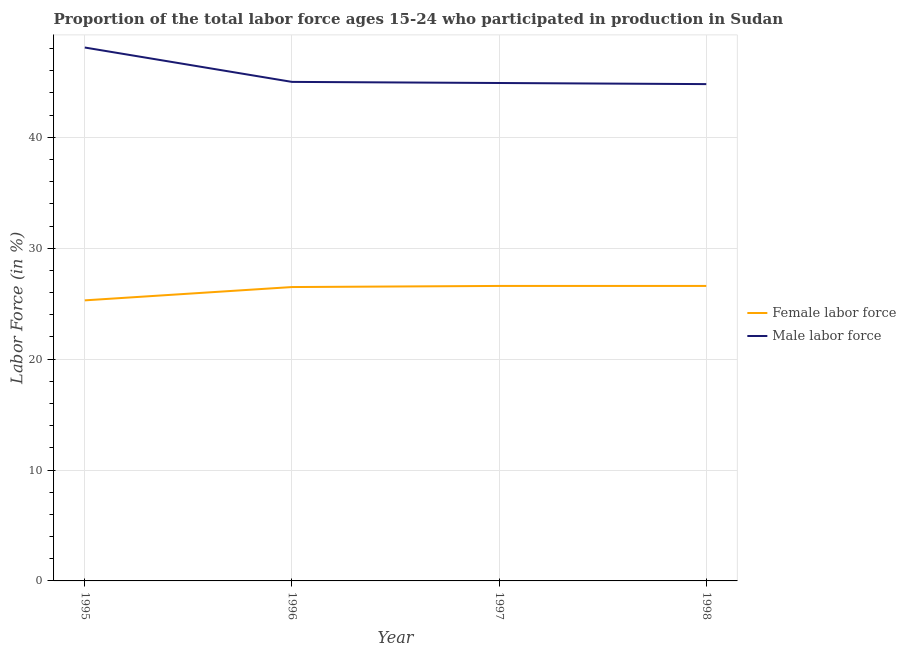Does the line corresponding to percentage of female labor force intersect with the line corresponding to percentage of male labour force?
Provide a short and direct response. No. What is the percentage of female labor force in 1995?
Keep it short and to the point. 25.3. Across all years, what is the maximum percentage of male labour force?
Your answer should be very brief. 48.1. Across all years, what is the minimum percentage of female labor force?
Ensure brevity in your answer.  25.3. In which year was the percentage of female labor force maximum?
Provide a succinct answer. 1997. What is the total percentage of male labour force in the graph?
Give a very brief answer. 182.8. What is the difference between the percentage of male labour force in 1996 and that in 1997?
Keep it short and to the point. 0.1. What is the difference between the percentage of male labour force in 1997 and the percentage of female labor force in 1995?
Your answer should be very brief. 19.6. What is the average percentage of male labour force per year?
Give a very brief answer. 45.7. In the year 1997, what is the difference between the percentage of female labor force and percentage of male labour force?
Give a very brief answer. -18.3. What is the ratio of the percentage of female labor force in 1996 to that in 1998?
Your answer should be very brief. 1. What is the difference between the highest and the second highest percentage of male labour force?
Provide a succinct answer. 3.1. What is the difference between the highest and the lowest percentage of male labour force?
Keep it short and to the point. 3.3. In how many years, is the percentage of female labor force greater than the average percentage of female labor force taken over all years?
Provide a succinct answer. 3. Does the percentage of male labour force monotonically increase over the years?
Offer a very short reply. No. How many lines are there?
Your response must be concise. 2. What is the difference between two consecutive major ticks on the Y-axis?
Provide a short and direct response. 10. Does the graph contain any zero values?
Provide a short and direct response. No. Where does the legend appear in the graph?
Offer a terse response. Center right. What is the title of the graph?
Offer a terse response. Proportion of the total labor force ages 15-24 who participated in production in Sudan. What is the label or title of the X-axis?
Ensure brevity in your answer.  Year. What is the label or title of the Y-axis?
Keep it short and to the point. Labor Force (in %). What is the Labor Force (in %) in Female labor force in 1995?
Make the answer very short. 25.3. What is the Labor Force (in %) in Male labor force in 1995?
Make the answer very short. 48.1. What is the Labor Force (in %) of Female labor force in 1997?
Keep it short and to the point. 26.6. What is the Labor Force (in %) in Male labor force in 1997?
Your answer should be compact. 44.9. What is the Labor Force (in %) of Female labor force in 1998?
Ensure brevity in your answer.  26.6. What is the Labor Force (in %) of Male labor force in 1998?
Give a very brief answer. 44.8. Across all years, what is the maximum Labor Force (in %) of Female labor force?
Your answer should be very brief. 26.6. Across all years, what is the maximum Labor Force (in %) of Male labor force?
Make the answer very short. 48.1. Across all years, what is the minimum Labor Force (in %) in Female labor force?
Ensure brevity in your answer.  25.3. Across all years, what is the minimum Labor Force (in %) of Male labor force?
Offer a terse response. 44.8. What is the total Labor Force (in %) in Female labor force in the graph?
Offer a very short reply. 105. What is the total Labor Force (in %) in Male labor force in the graph?
Offer a terse response. 182.8. What is the difference between the Labor Force (in %) in Male labor force in 1995 and that in 1996?
Give a very brief answer. 3.1. What is the difference between the Labor Force (in %) in Female labor force in 1995 and that in 1997?
Your answer should be compact. -1.3. What is the difference between the Labor Force (in %) in Male labor force in 1995 and that in 1997?
Provide a succinct answer. 3.2. What is the difference between the Labor Force (in %) in Female labor force in 1995 and that in 1998?
Your response must be concise. -1.3. What is the difference between the Labor Force (in %) of Female labor force in 1996 and that in 1998?
Your response must be concise. -0.1. What is the difference between the Labor Force (in %) in Male labor force in 1996 and that in 1998?
Keep it short and to the point. 0.2. What is the difference between the Labor Force (in %) in Female labor force in 1997 and that in 1998?
Your answer should be compact. 0. What is the difference between the Labor Force (in %) in Female labor force in 1995 and the Labor Force (in %) in Male labor force in 1996?
Make the answer very short. -19.7. What is the difference between the Labor Force (in %) in Female labor force in 1995 and the Labor Force (in %) in Male labor force in 1997?
Provide a short and direct response. -19.6. What is the difference between the Labor Force (in %) in Female labor force in 1995 and the Labor Force (in %) in Male labor force in 1998?
Give a very brief answer. -19.5. What is the difference between the Labor Force (in %) in Female labor force in 1996 and the Labor Force (in %) in Male labor force in 1997?
Offer a very short reply. -18.4. What is the difference between the Labor Force (in %) in Female labor force in 1996 and the Labor Force (in %) in Male labor force in 1998?
Your response must be concise. -18.3. What is the difference between the Labor Force (in %) of Female labor force in 1997 and the Labor Force (in %) of Male labor force in 1998?
Offer a very short reply. -18.2. What is the average Labor Force (in %) in Female labor force per year?
Your response must be concise. 26.25. What is the average Labor Force (in %) in Male labor force per year?
Give a very brief answer. 45.7. In the year 1995, what is the difference between the Labor Force (in %) of Female labor force and Labor Force (in %) of Male labor force?
Your response must be concise. -22.8. In the year 1996, what is the difference between the Labor Force (in %) in Female labor force and Labor Force (in %) in Male labor force?
Provide a succinct answer. -18.5. In the year 1997, what is the difference between the Labor Force (in %) in Female labor force and Labor Force (in %) in Male labor force?
Keep it short and to the point. -18.3. In the year 1998, what is the difference between the Labor Force (in %) of Female labor force and Labor Force (in %) of Male labor force?
Keep it short and to the point. -18.2. What is the ratio of the Labor Force (in %) of Female labor force in 1995 to that in 1996?
Give a very brief answer. 0.95. What is the ratio of the Labor Force (in %) in Male labor force in 1995 to that in 1996?
Offer a very short reply. 1.07. What is the ratio of the Labor Force (in %) of Female labor force in 1995 to that in 1997?
Ensure brevity in your answer.  0.95. What is the ratio of the Labor Force (in %) in Male labor force in 1995 to that in 1997?
Provide a succinct answer. 1.07. What is the ratio of the Labor Force (in %) of Female labor force in 1995 to that in 1998?
Your answer should be compact. 0.95. What is the ratio of the Labor Force (in %) in Male labor force in 1995 to that in 1998?
Provide a short and direct response. 1.07. What is the ratio of the Labor Force (in %) of Female labor force in 1996 to that in 1997?
Make the answer very short. 1. What is the ratio of the Labor Force (in %) in Male labor force in 1996 to that in 1997?
Provide a succinct answer. 1. What is the ratio of the Labor Force (in %) of Male labor force in 1996 to that in 1998?
Make the answer very short. 1. What is the difference between the highest and the second highest Labor Force (in %) in Female labor force?
Provide a succinct answer. 0. What is the difference between the highest and the second highest Labor Force (in %) in Male labor force?
Offer a very short reply. 3.1. 